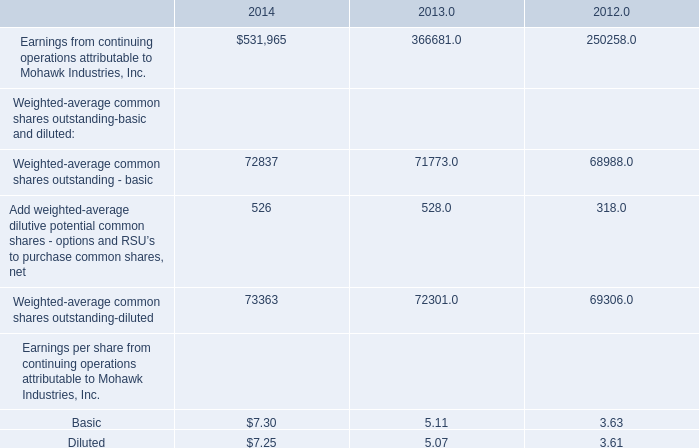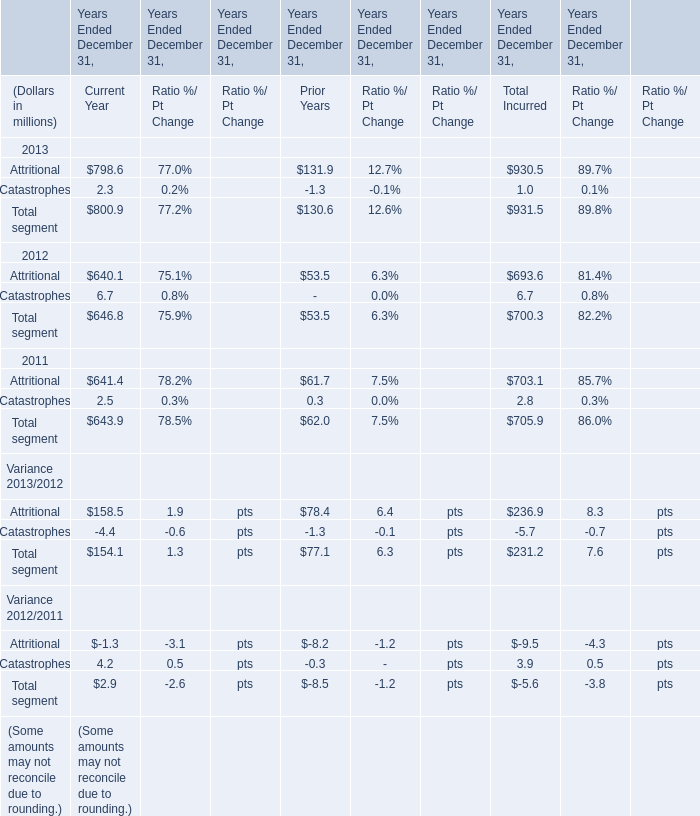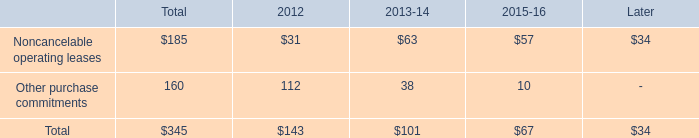How many element exceed the average of Attritional in 2013 for Current Year ?? 
Answer: 2. 